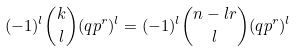Convert formula to latex. <formula><loc_0><loc_0><loc_500><loc_500>( - 1 ) ^ { l } \binom { k } { l } ( q p ^ { r } ) ^ { l } = ( - 1 ) ^ { l } \binom { n - l r } { l } ( q p ^ { r } ) ^ { l }</formula> 